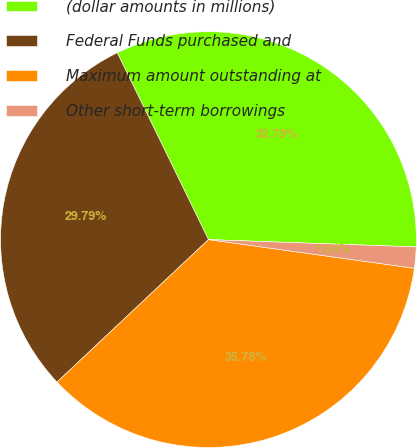<chart> <loc_0><loc_0><loc_500><loc_500><pie_chart><fcel>(dollar amounts in millions)<fcel>Federal Funds purchased and<fcel>Maximum amount outstanding at<fcel>Other short-term borrowings<nl><fcel>32.79%<fcel>29.79%<fcel>35.78%<fcel>1.64%<nl></chart> 